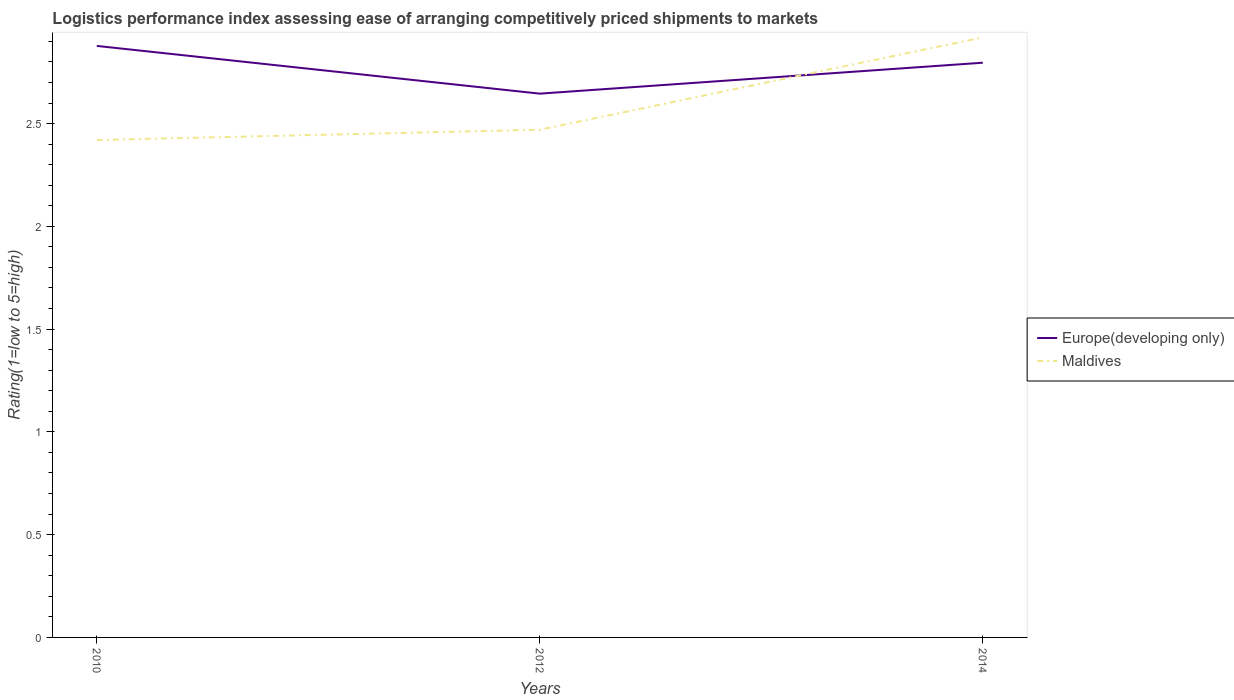How many different coloured lines are there?
Your answer should be very brief. 2. Does the line corresponding to Europe(developing only) intersect with the line corresponding to Maldives?
Your response must be concise. Yes. Across all years, what is the maximum Logistic performance index in Europe(developing only)?
Ensure brevity in your answer.  2.65. In which year was the Logistic performance index in Europe(developing only) maximum?
Provide a succinct answer. 2012. What is the total Logistic performance index in Europe(developing only) in the graph?
Your response must be concise. -0.15. What is the difference between the highest and the second highest Logistic performance index in Maldives?
Ensure brevity in your answer.  0.5. How many lines are there?
Offer a terse response. 2. How many years are there in the graph?
Ensure brevity in your answer.  3. What is the difference between two consecutive major ticks on the Y-axis?
Your answer should be compact. 0.5. Does the graph contain any zero values?
Provide a short and direct response. No. Where does the legend appear in the graph?
Your answer should be very brief. Center right. What is the title of the graph?
Provide a short and direct response. Logistics performance index assessing ease of arranging competitively priced shipments to markets. What is the label or title of the Y-axis?
Offer a terse response. Rating(1=low to 5=high). What is the Rating(1=low to 5=high) in Europe(developing only) in 2010?
Give a very brief answer. 2.88. What is the Rating(1=low to 5=high) of Maldives in 2010?
Offer a terse response. 2.42. What is the Rating(1=low to 5=high) of Europe(developing only) in 2012?
Your answer should be compact. 2.65. What is the Rating(1=low to 5=high) of Maldives in 2012?
Your answer should be compact. 2.47. What is the Rating(1=low to 5=high) in Europe(developing only) in 2014?
Your answer should be very brief. 2.8. What is the Rating(1=low to 5=high) of Maldives in 2014?
Provide a short and direct response. 2.92. Across all years, what is the maximum Rating(1=low to 5=high) of Europe(developing only)?
Provide a succinct answer. 2.88. Across all years, what is the maximum Rating(1=low to 5=high) of Maldives?
Your answer should be very brief. 2.92. Across all years, what is the minimum Rating(1=low to 5=high) in Europe(developing only)?
Your response must be concise. 2.65. Across all years, what is the minimum Rating(1=low to 5=high) of Maldives?
Your response must be concise. 2.42. What is the total Rating(1=low to 5=high) in Europe(developing only) in the graph?
Your answer should be very brief. 8.32. What is the total Rating(1=low to 5=high) in Maldives in the graph?
Give a very brief answer. 7.81. What is the difference between the Rating(1=low to 5=high) of Europe(developing only) in 2010 and that in 2012?
Give a very brief answer. 0.23. What is the difference between the Rating(1=low to 5=high) of Maldives in 2010 and that in 2012?
Make the answer very short. -0.05. What is the difference between the Rating(1=low to 5=high) in Europe(developing only) in 2010 and that in 2014?
Offer a very short reply. 0.08. What is the difference between the Rating(1=low to 5=high) in Maldives in 2010 and that in 2014?
Your answer should be compact. -0.5. What is the difference between the Rating(1=low to 5=high) of Europe(developing only) in 2012 and that in 2014?
Your answer should be compact. -0.15. What is the difference between the Rating(1=low to 5=high) in Maldives in 2012 and that in 2014?
Your answer should be compact. -0.45. What is the difference between the Rating(1=low to 5=high) in Europe(developing only) in 2010 and the Rating(1=low to 5=high) in Maldives in 2012?
Your response must be concise. 0.41. What is the difference between the Rating(1=low to 5=high) of Europe(developing only) in 2010 and the Rating(1=low to 5=high) of Maldives in 2014?
Your answer should be compact. -0.04. What is the difference between the Rating(1=low to 5=high) of Europe(developing only) in 2012 and the Rating(1=low to 5=high) of Maldives in 2014?
Make the answer very short. -0.27. What is the average Rating(1=low to 5=high) in Europe(developing only) per year?
Provide a short and direct response. 2.77. What is the average Rating(1=low to 5=high) of Maldives per year?
Provide a succinct answer. 2.6. In the year 2010, what is the difference between the Rating(1=low to 5=high) of Europe(developing only) and Rating(1=low to 5=high) of Maldives?
Offer a terse response. 0.46. In the year 2012, what is the difference between the Rating(1=low to 5=high) in Europe(developing only) and Rating(1=low to 5=high) in Maldives?
Ensure brevity in your answer.  0.18. In the year 2014, what is the difference between the Rating(1=low to 5=high) in Europe(developing only) and Rating(1=low to 5=high) in Maldives?
Make the answer very short. -0.12. What is the ratio of the Rating(1=low to 5=high) of Europe(developing only) in 2010 to that in 2012?
Ensure brevity in your answer.  1.09. What is the ratio of the Rating(1=low to 5=high) in Maldives in 2010 to that in 2012?
Provide a succinct answer. 0.98. What is the ratio of the Rating(1=low to 5=high) of Europe(developing only) in 2010 to that in 2014?
Offer a terse response. 1.03. What is the ratio of the Rating(1=low to 5=high) of Maldives in 2010 to that in 2014?
Your answer should be compact. 0.83. What is the ratio of the Rating(1=low to 5=high) of Europe(developing only) in 2012 to that in 2014?
Your answer should be very brief. 0.95. What is the ratio of the Rating(1=low to 5=high) of Maldives in 2012 to that in 2014?
Ensure brevity in your answer.  0.85. What is the difference between the highest and the second highest Rating(1=low to 5=high) in Europe(developing only)?
Ensure brevity in your answer.  0.08. What is the difference between the highest and the second highest Rating(1=low to 5=high) of Maldives?
Keep it short and to the point. 0.45. What is the difference between the highest and the lowest Rating(1=low to 5=high) in Europe(developing only)?
Ensure brevity in your answer.  0.23. What is the difference between the highest and the lowest Rating(1=low to 5=high) in Maldives?
Give a very brief answer. 0.5. 